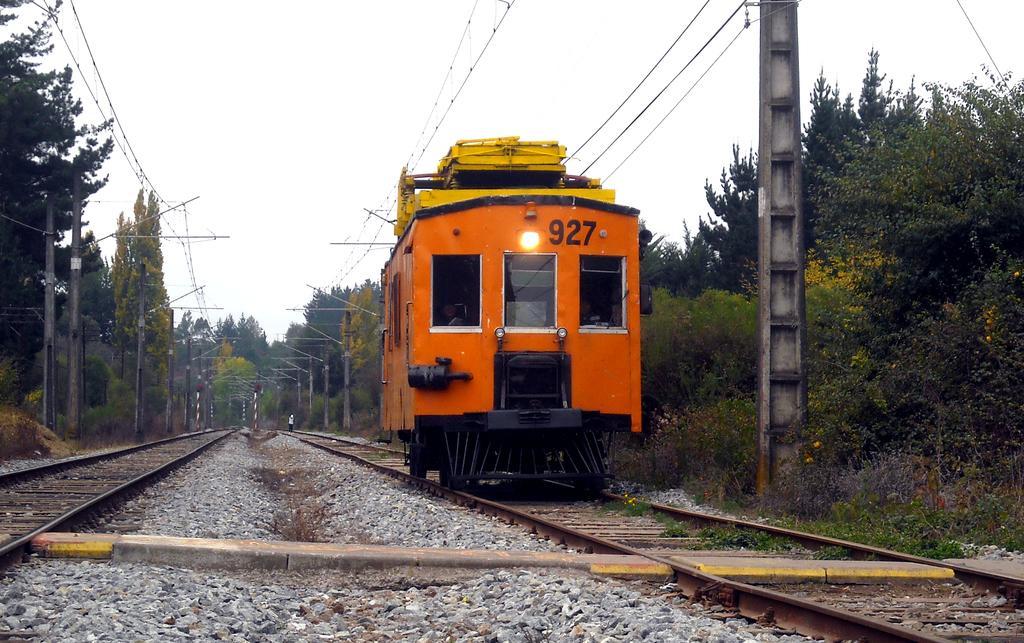In one or two sentences, can you explain what this image depicts? In the image there is a train compartment on the railway track and around the railway track there are many trees, poles and there are a lot of wires attached to those poles. 